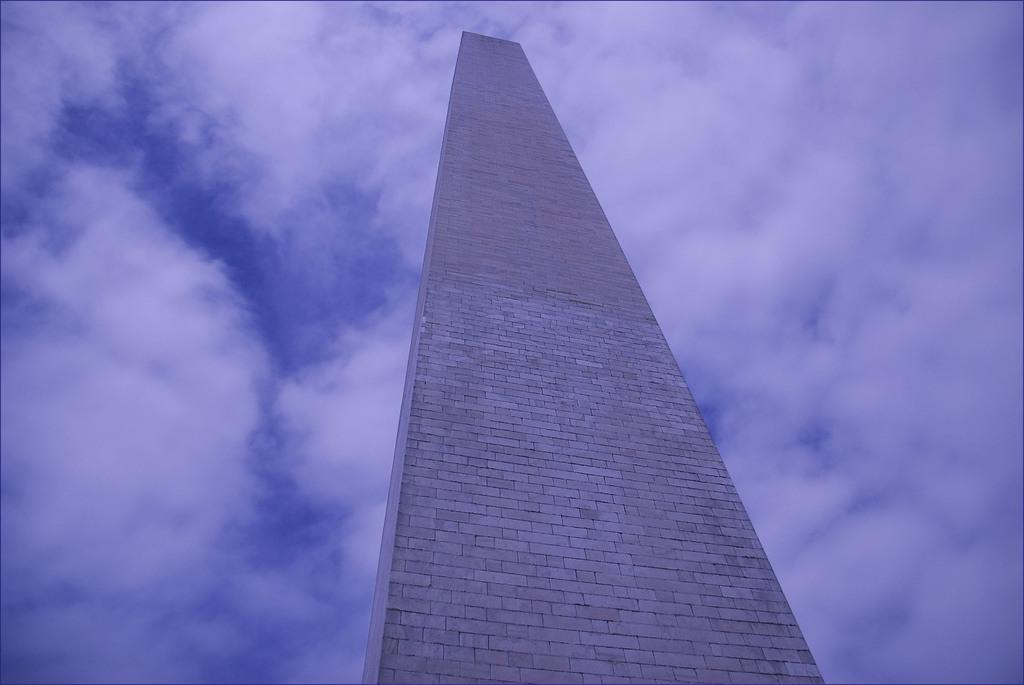What is present in the image that serves as a barrier or divider? There is a wall in the image. What can be seen in the background of the image? The sky is visible in the background of the image. What type of can is visible in the image? There is no can present in the image; it only features a wall and the sky. What type of laborer can be seen working on the wall in the image? There is no laborer present in the image; it only features a wall and the sky. 